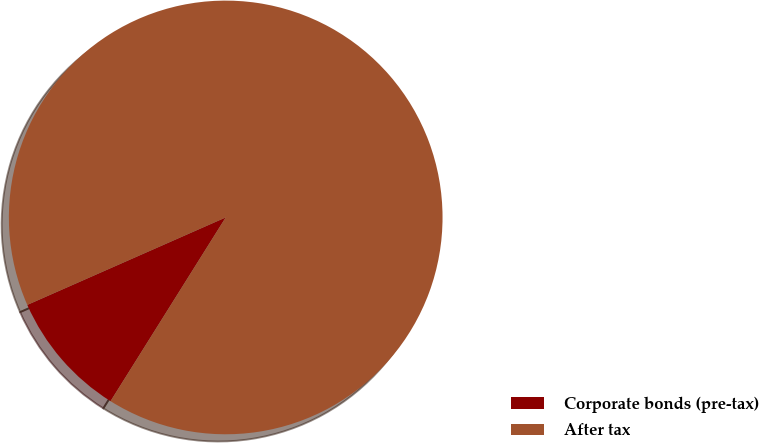Convert chart to OTSL. <chart><loc_0><loc_0><loc_500><loc_500><pie_chart><fcel>Corporate bonds (pre-tax)<fcel>After tax<nl><fcel>9.48%<fcel>90.52%<nl></chart> 